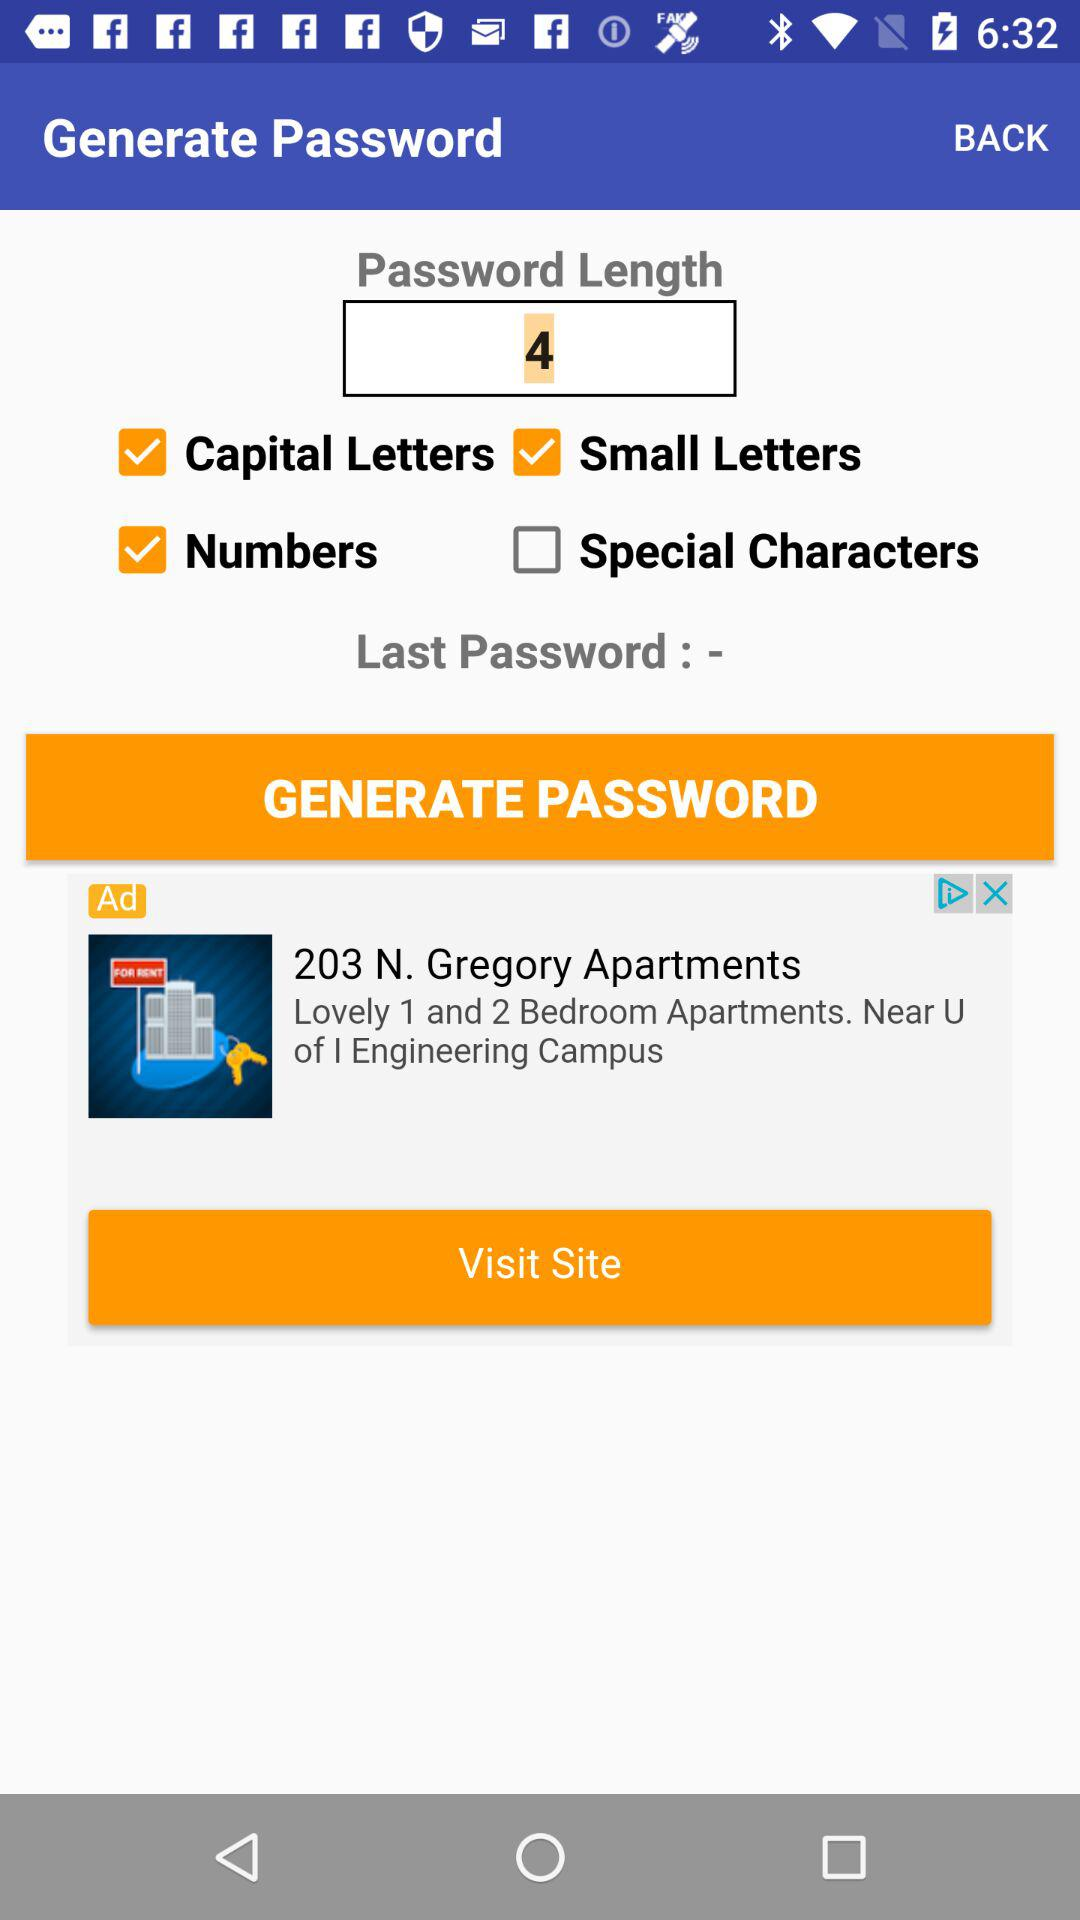What is the status of "Special Characters"? The status of "Special Characters" is "off". 